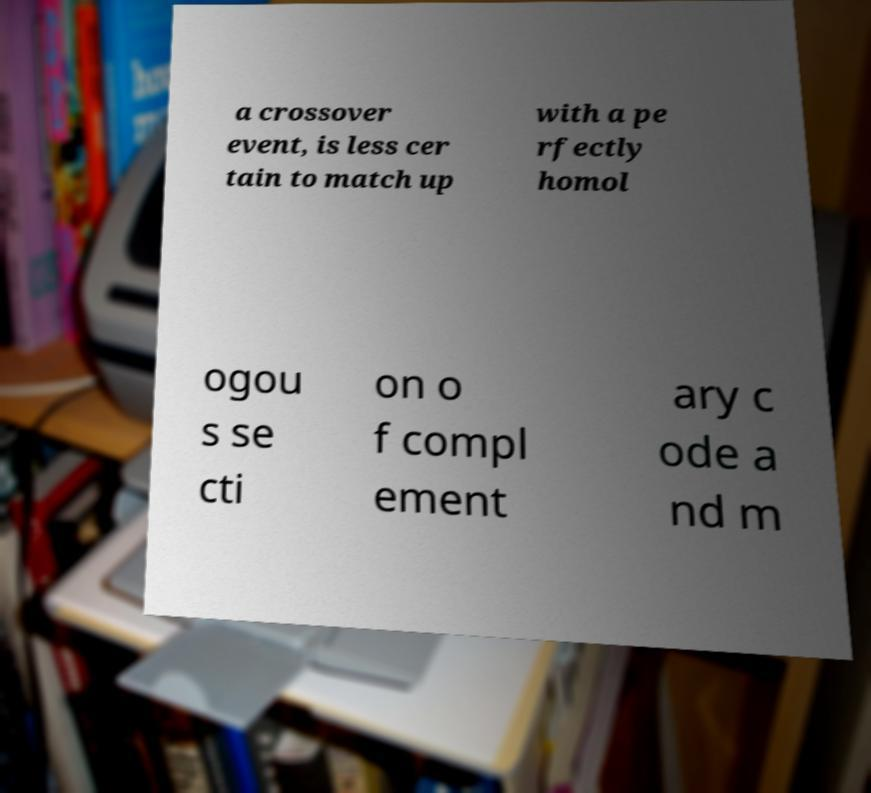Could you assist in decoding the text presented in this image and type it out clearly? a crossover event, is less cer tain to match up with a pe rfectly homol ogou s se cti on o f compl ement ary c ode a nd m 